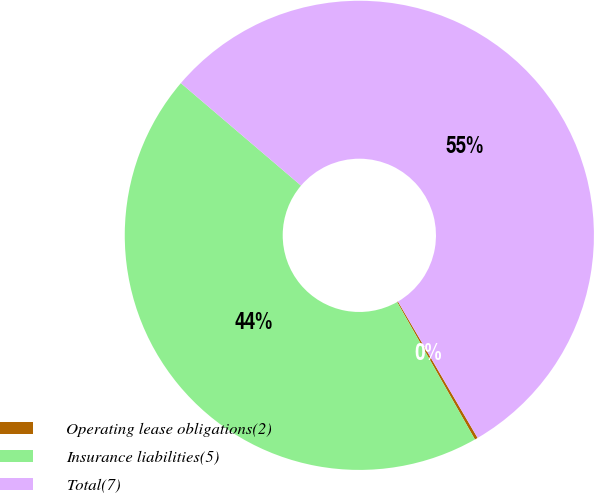<chart> <loc_0><loc_0><loc_500><loc_500><pie_chart><fcel>Operating lease obligations(2)<fcel>Insurance liabilities(5)<fcel>Total(7)<nl><fcel>0.21%<fcel>44.44%<fcel>55.35%<nl></chart> 